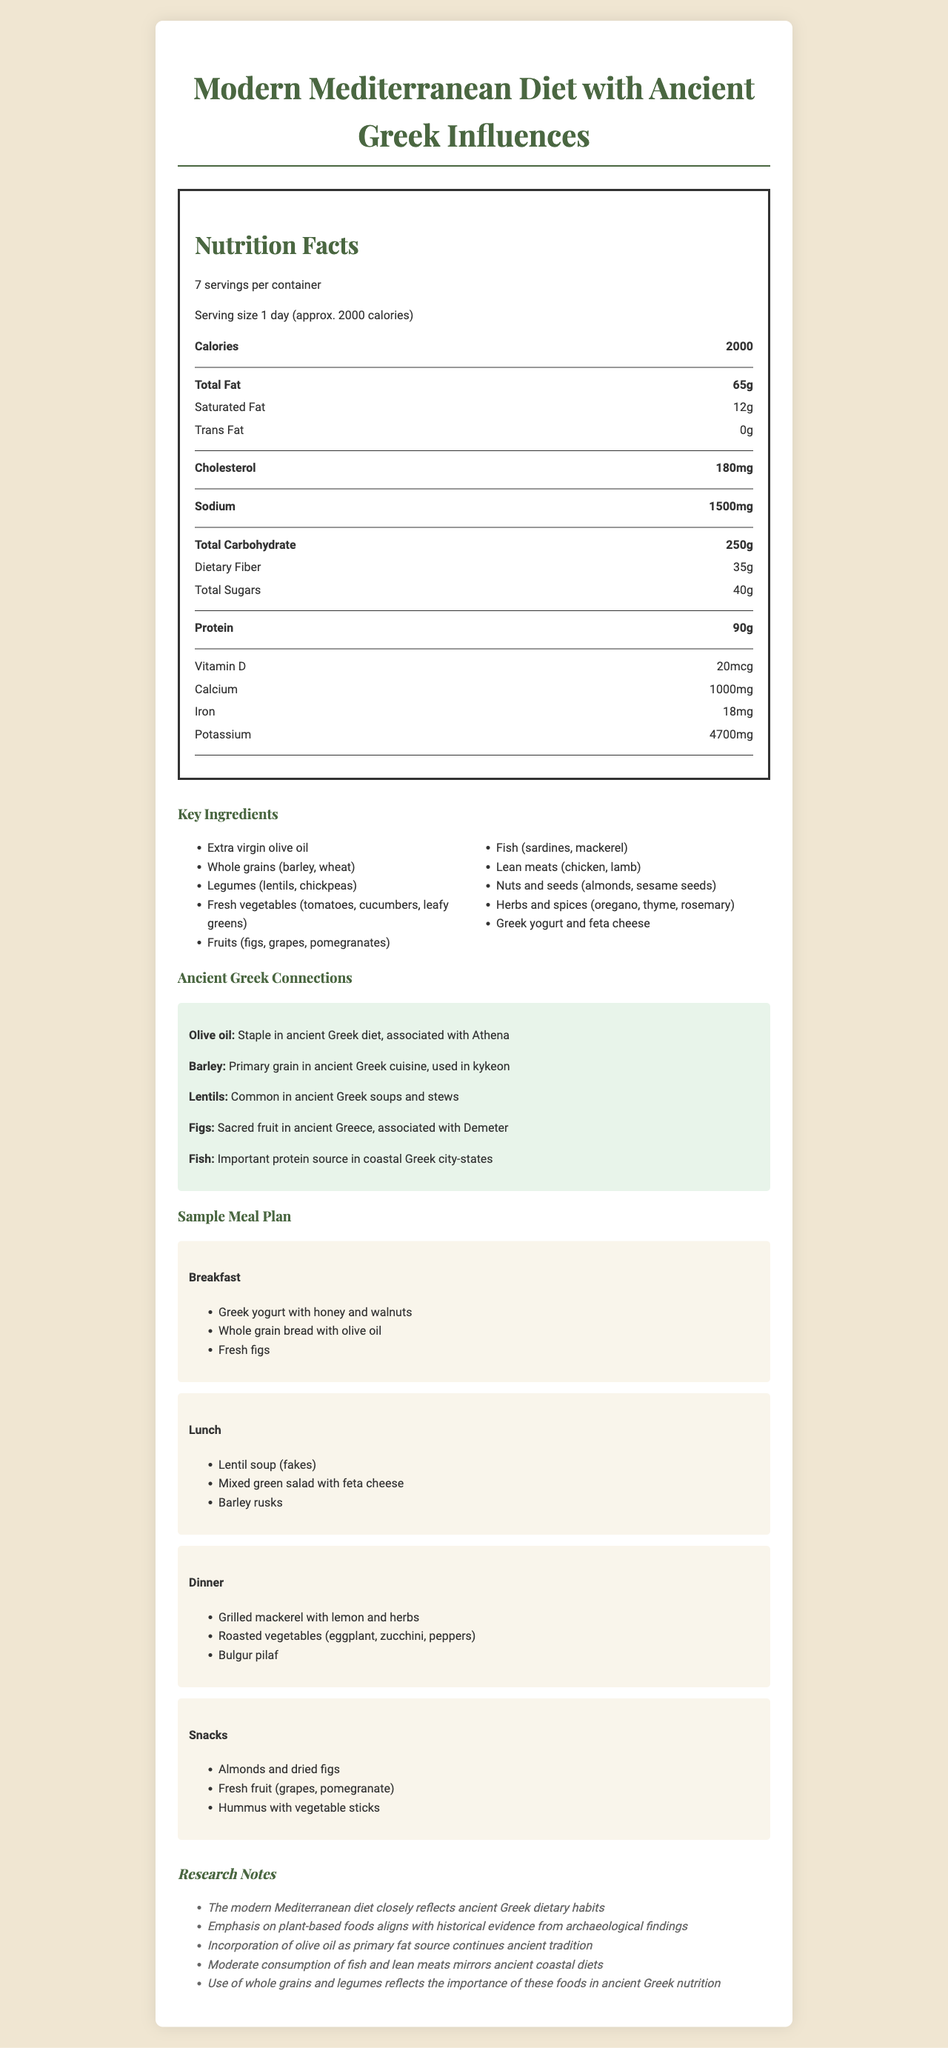What is the total fat content per serving? The document states that the total fat content per serving is 65 grams in the "Nutrition Facts" section.
Answer: 65 grams How many servings are in the container? Under the "Nutrition Facts" section, the document states that there are 7 servings per container.
Answer: 7 servings Which meal includes Greek yogurt with honey and walnuts? In the "Sample Meal Plan" section, under "Breakfast," it lists "Greek yogurt with honey and walnuts."
Answer: Breakfast What is the historical context of lentils in ancient Greek cuisine? Under the "Ancient Greek Connections" section, the historical context for lentils is given as "Common in ancient Greek soups and stews."
Answer: Common in ancient Greek soups and stews How many calories are in one serving? The "Nutrition Facts" section lists 2000 calories per serving.
Answer: 2000 Which of the following vitamins or minerals is present in the highest amount? A. Vitamin D B. Calcium C. Iron D. Potassium The document lists the amount of each: Vitamin D (20 mcg), Calcium (1000 mg), Iron (18 mg), Potassium (4700 mg). Potassium is the highest.
Answer: D What is the primary fat source in the modern Mediterranean diet? The "Research Notes" section mentions that the incorporation of olive oil as the primary fat source continues ancient tradition.
Answer: Olive oil True or False: The total carbohydrate content per serving is 35 grams. The "Nutrition Facts" section shows that the total carbohydrate content is 250 grams, not 35 grams.
Answer: False What is the main idea of this document? The document provides details about the nutritional breakdown of the meal plan, key ingredients, their historical context tied to ancient Greek cuisine, sample meals, and research notes about the alignment with ancient dietary habits.
Answer: It describes a modern Mediterranean diet meal plan with nutritional facts and historical connections to ancient Greek cuisine. Who was the Greek goddess associated with olive oil? Under the "Ancient Greek Connections" section, it is mentioned that olive oil is associated with Athena.
Answer: Athena Which meal includes grilled mackerel with lemon and herbs? A. Breakfast B. Lunch C. Dinner D. Snacks The "Sample Meal Plan" section under "Dinner" lists grilled mackerel with lemon and herbs.
Answer: C What primary grain was used in ancient Greek cuisine? The "Ancient Greek Connections" section states that barley was the primary grain used in ancient Greek cuisine.
Answer: Barley Can you determine the exact brand of Greek yogurt used in the meal plan? The document does not provide any information about specific brands of Greek yogurt.
Answer: Cannot be determined What is the total protein content per serving? The "Nutrition Facts" section lists the total protein content as 90 grams per serving.
Answer: 90 grams Which fruits are considered sacred in ancient Greek culture according to the document? The "Ancient Greek Connections" section mentions that figs were regarded as a sacred fruit in ancient Greece and were associated with Demeter.
Answer: Figs Which snack includes a source of protein? Under the "Snacks" section in the "Sample Meal Plan," one of the snacks is "Almonds and dried figs," with almonds being a source of protein.
Answer: Almonds and dried figs What historical context is associated with fish in the ancient Greek diet? The "Ancient Greek Connections" section describes fish as an important protein source in coastal Greek city-states.
Answer: Important protein source in coastal Greek city-states 